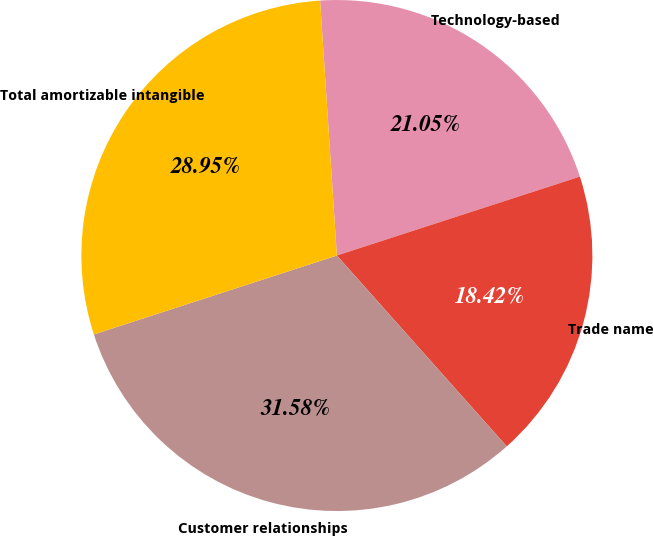<chart> <loc_0><loc_0><loc_500><loc_500><pie_chart><fcel>Technology-based<fcel>Trade name<fcel>Customer relationships<fcel>Total amortizable intangible<nl><fcel>21.05%<fcel>18.42%<fcel>31.58%<fcel>28.95%<nl></chart> 